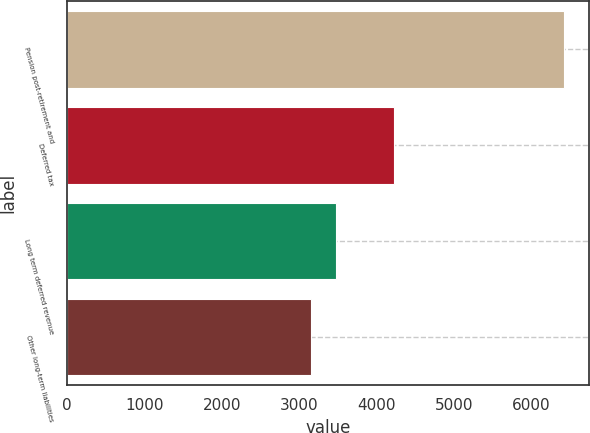<chart> <loc_0><loc_0><loc_500><loc_500><bar_chart><fcel>Pension post-retirement and<fcel>Deferred tax<fcel>Long term deferred revenue<fcel>Other long-term liabilities<nl><fcel>6427<fcel>4230<fcel>3474.1<fcel>3146<nl></chart> 